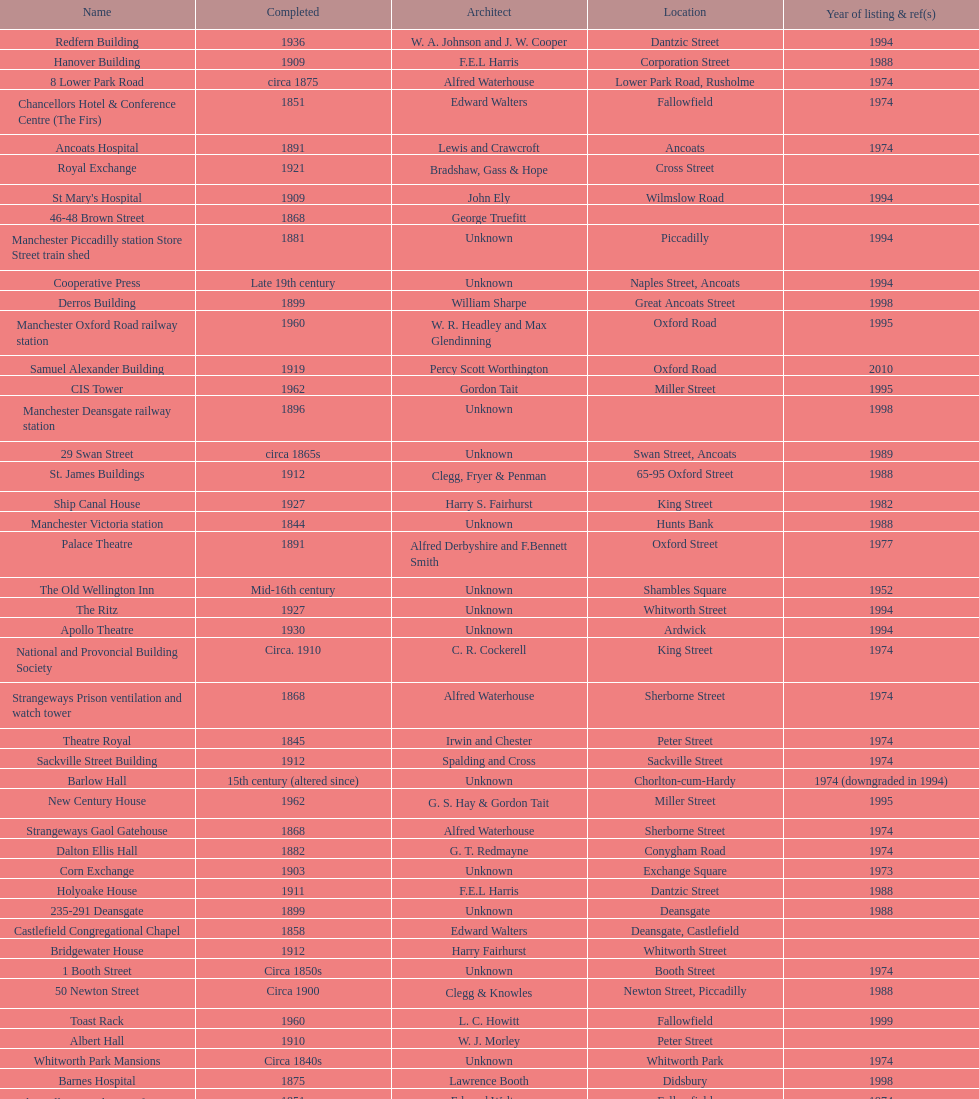Which two buildings were listed before 1974? The Old Wellington Inn, Smithfield Market Hall. 